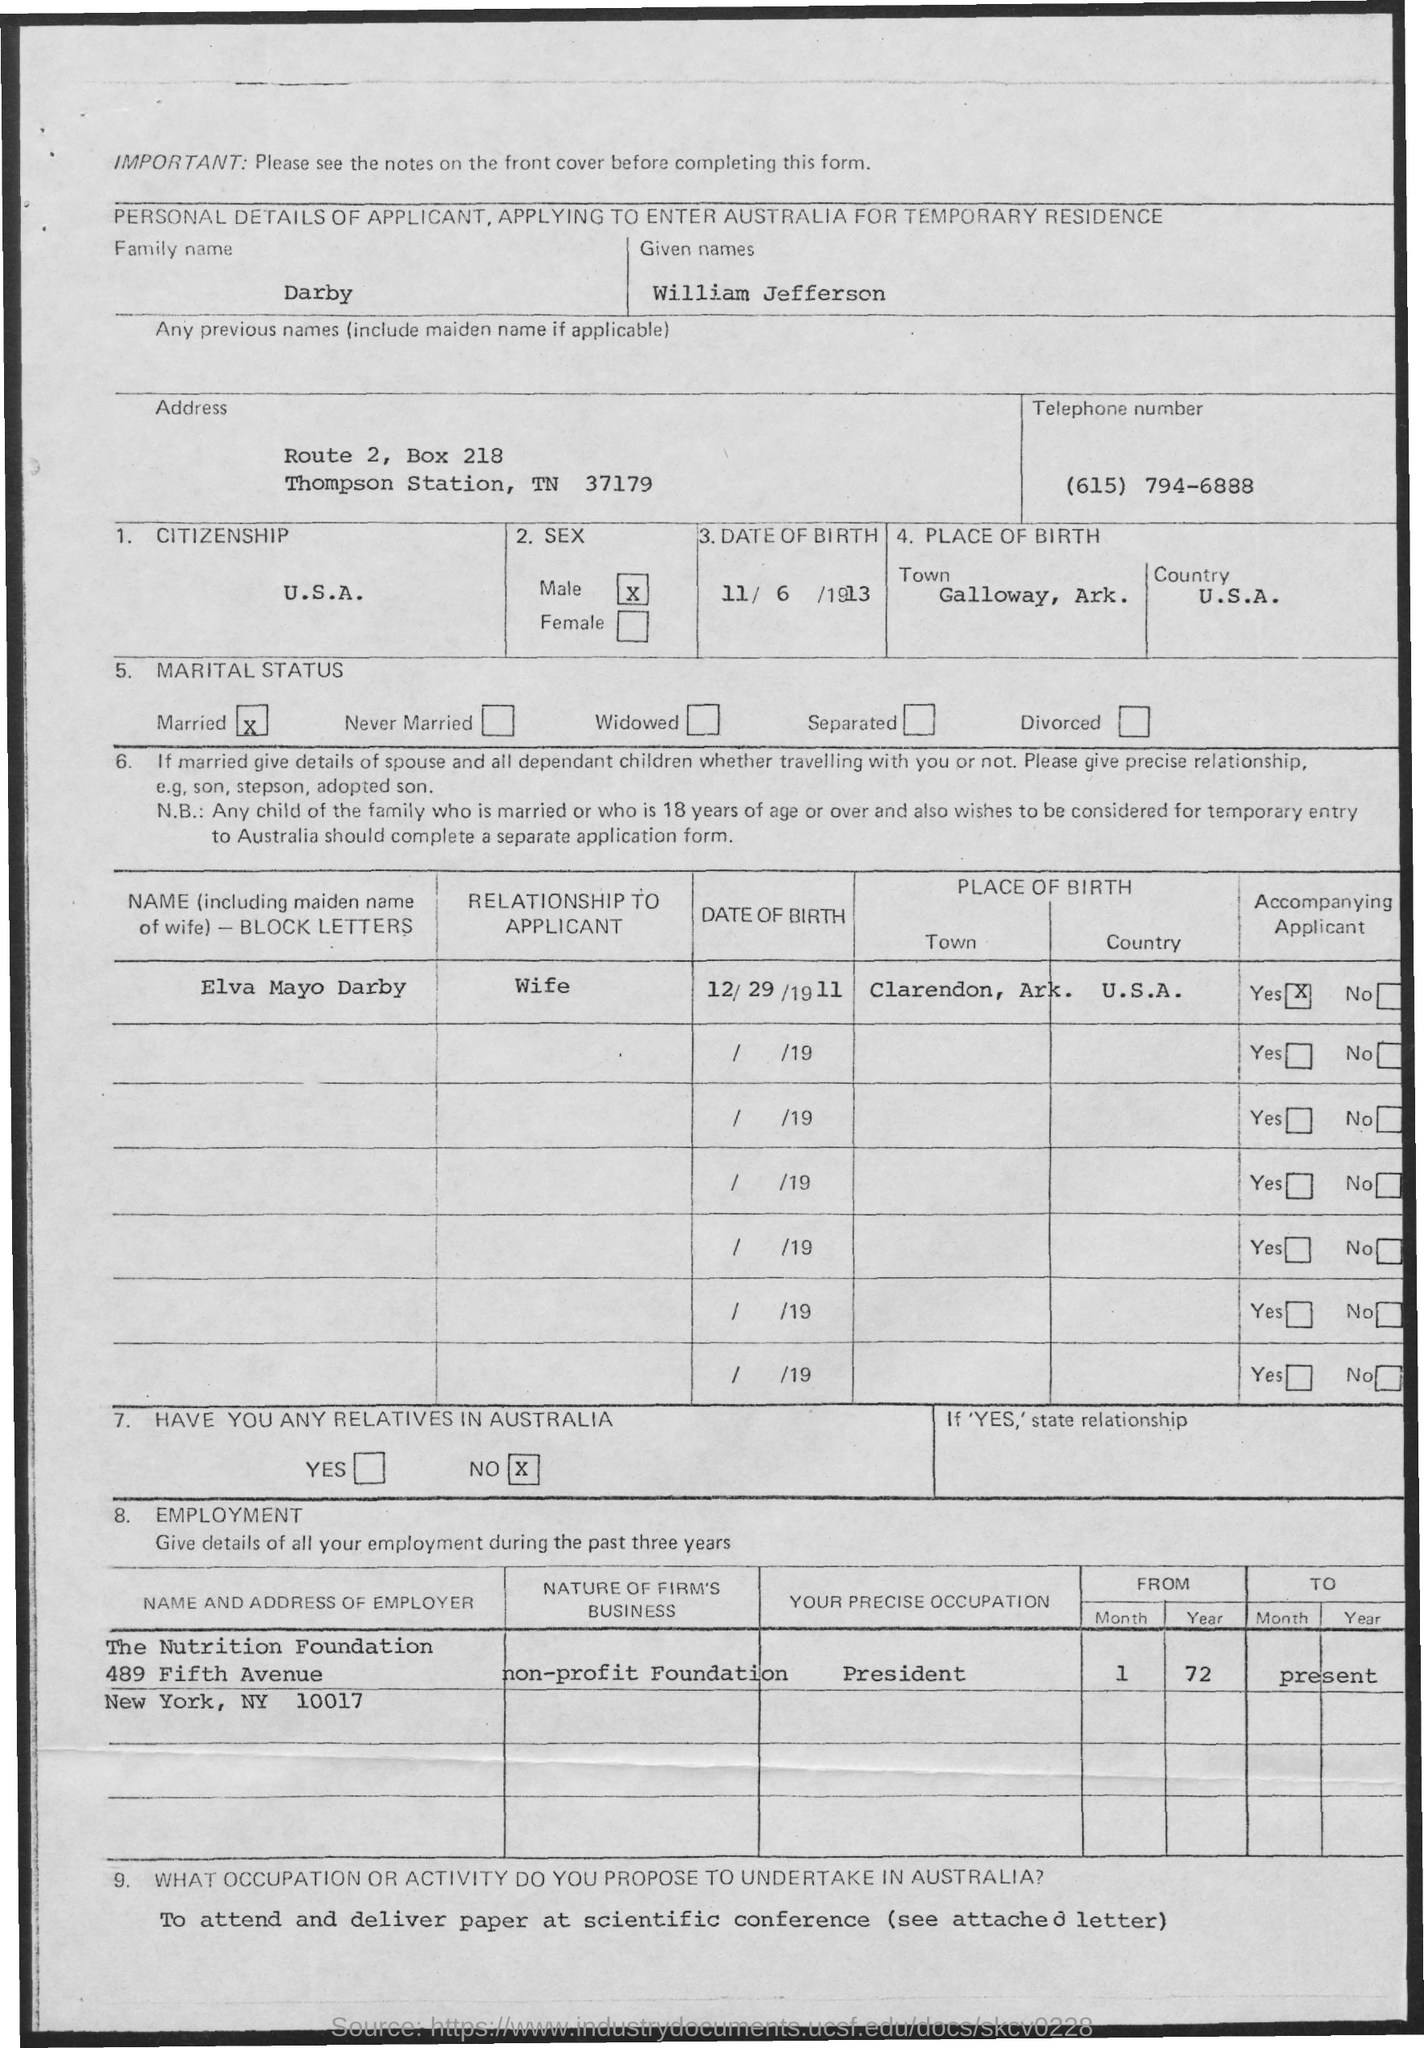Mention a couple of crucial points in this snapshot. William Jefferson Darby is a citizen of the United States of America. William Jefferson Darby was born on November 6, 1913. William Jefferson Darby was born in Galloway, Arkansas, which is his birthplace. The telephone number mentioned in the application is (615) 794-6888. William Jefferson Darby is married to Elva Mayo Darby. 